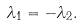Convert formula to latex. <formula><loc_0><loc_0><loc_500><loc_500>\lambda _ { 1 } = - \lambda _ { 2 } .</formula> 